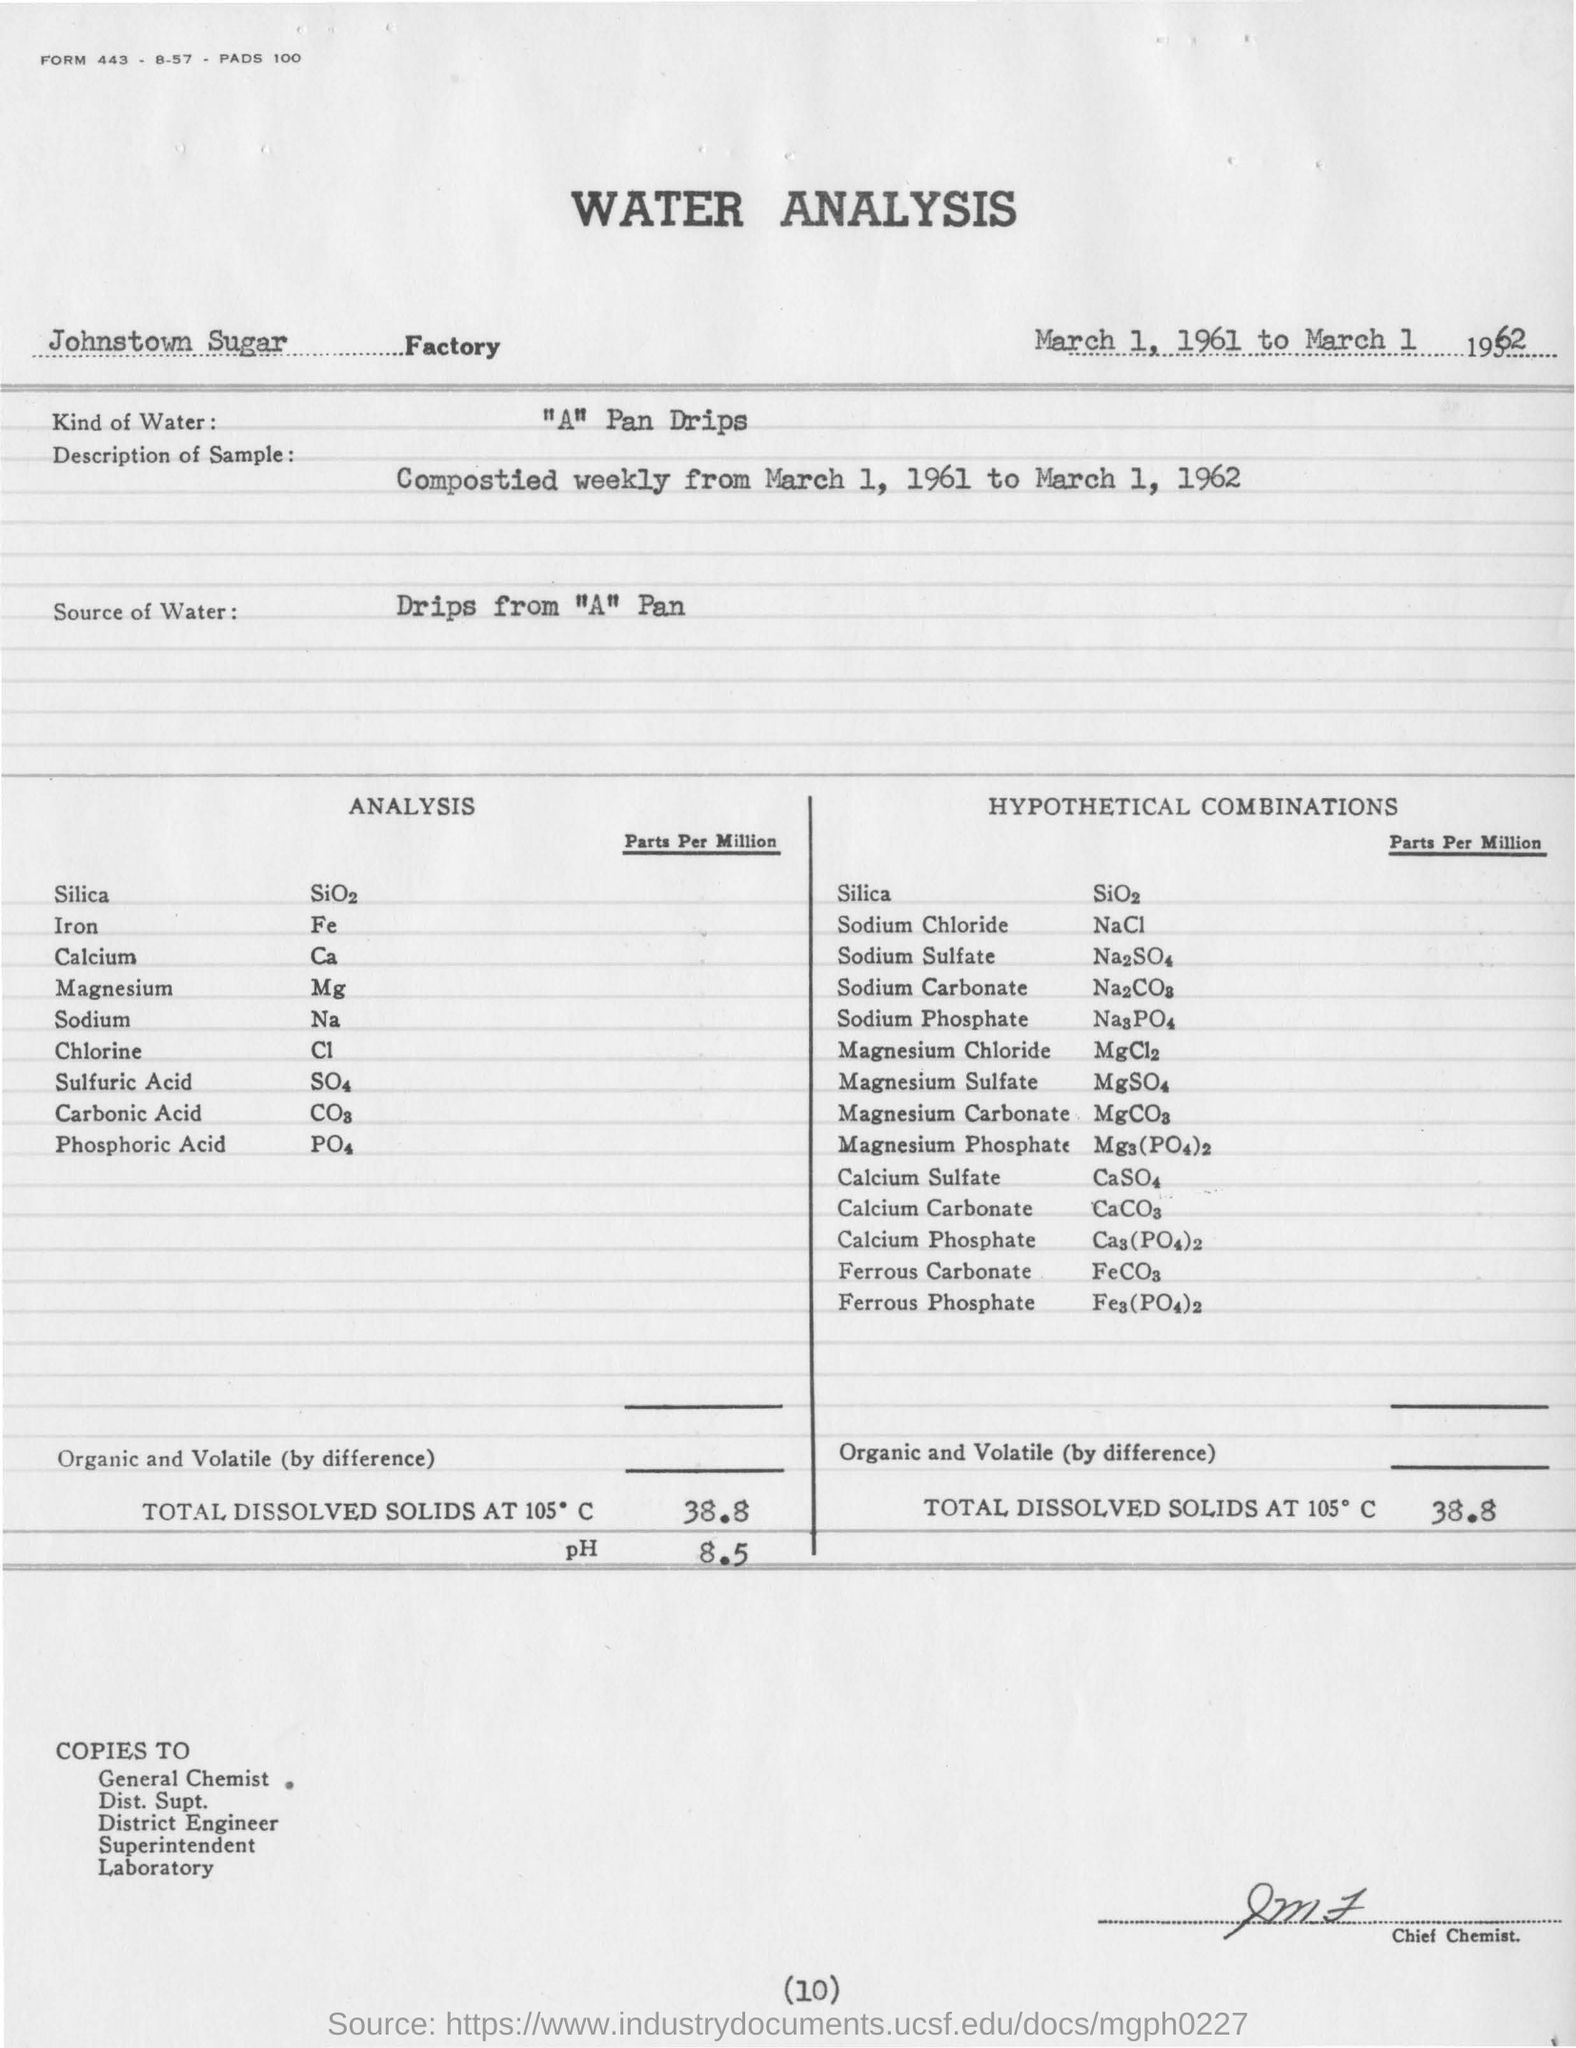What is the ph value obtained from the water analysis ?
Provide a succinct answer. 8.5. Name the factory in which the water analysis is conducted ?
Your answer should be compact. Johnstown Sugar Factory. What kind of water is used in water analysis ?
Your answer should be very brief. "A" Pan Drips. What is the amount of total dissolved solids at 105 degrees c?
Give a very brief answer. 38.8. For water analysis where is the source of the water ?
Offer a very short reply. Drips from "A" Pan. 